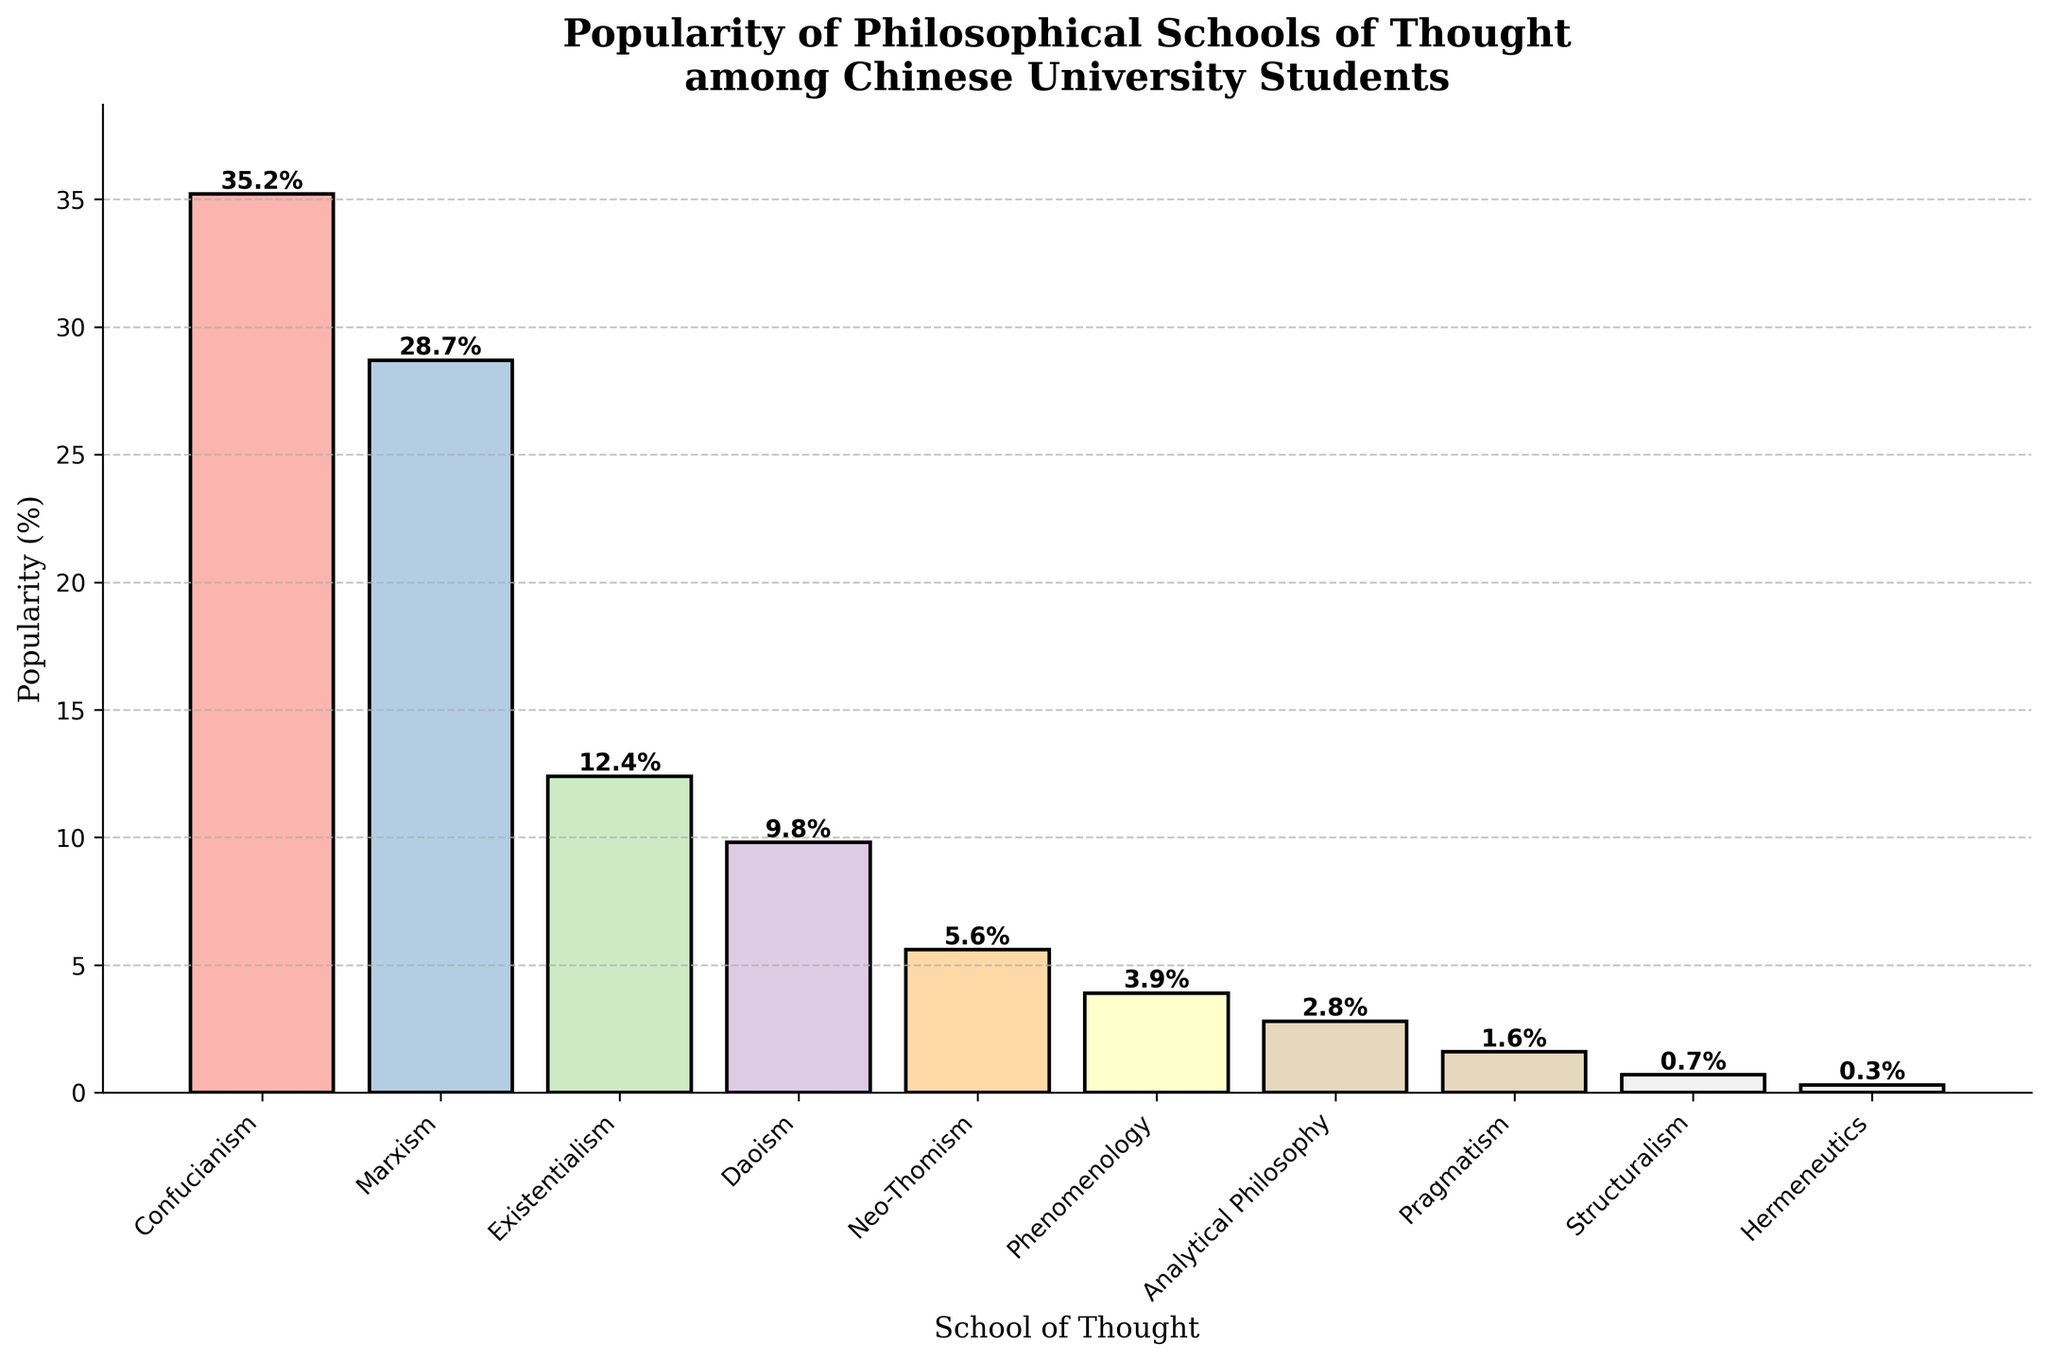Which philosophical school of thought is the most popular among Chinese university students? Confucianism has the highest bar in the chart, indicating that it is the most popular school of thought among Chinese university students, with a popularity of 35.2%.
Answer: Confucianism Which two schools of thought have the closest popularity percentages? Marxism at 28.7% and Existentialism at 12.4% are the most similar. Subtracting these percentages gives the smallest difference among the schools (28.7 - 12.4 = 16.3).
Answer: Marxism and Existentialism What is the combined popularity percentage of the three least popular philosophical schools of thought? The three least popular schools are Pragmatism (1.6%), Structuralism (0.7%), and Hermeneutics (0.3%). Adding these percentages together gives: 1.6 + 0.7 + 0.3 = 2.6%.
Answer: 2.6% How much more popular is Confucianism compared to Neo-Thomism? Confucianism's popularity is 35.2% and Neo-Thomism's is 5.6%. Subtracting these percentages gives: 35.2 - 5.6 = 29.6%.
Answer: 29.6% Which school of thought shows the third-highest popularity rate among Chinese university students? The third-highest bar corresponds to Existentialism, with a popularity rate of 12.4%.
Answer: Existentialism What is the average popularity percentage of the top five most popular schools of thought? Summing the popularity of the top five schools (Confucianism: 35.2, Marxism: 28.7, Existentialism: 12.4, Daoism: 9.8, Neo-Thomism: 5.6) gives a total of 91.7%. Dividing by 5 gives: 91.7 / 5 = 18.34%.
Answer: 18.34% How many schools of thought have a popularity percentage lower than 5% among Chinese university students? The schools of thought with popularity percentages lower than 5% are: Phenomenology (3.9%), Analytical Philosophy (2.8%), Pragmatism (1.6%), Structuralism (0.7%), and Hermeneutics (0.3%). This gives a total of 5 schools.
Answer: 5 What is the total popularity percentage of analytical and continental philosophical movements combined (Analytical Philosophy, Phenomenology, and Hermeneutics)? The popularity percentages are: Analytical Philosophy (2.8%), Phenomenology (3.9%), and Hermeneutics (0.3%). Adding these percentages gives: 2.8 + 3.9 + 0.3 = 7.0%.
Answer: 7.0% What is the difference in popularity percentage between Existentialism and Phenomenology? Existentialism has a popularity of 12.4% and Phenomenology has 3.9%. The difference between these values is 12.4 - 3.9 = 8.5%.
Answer: 8.5% 